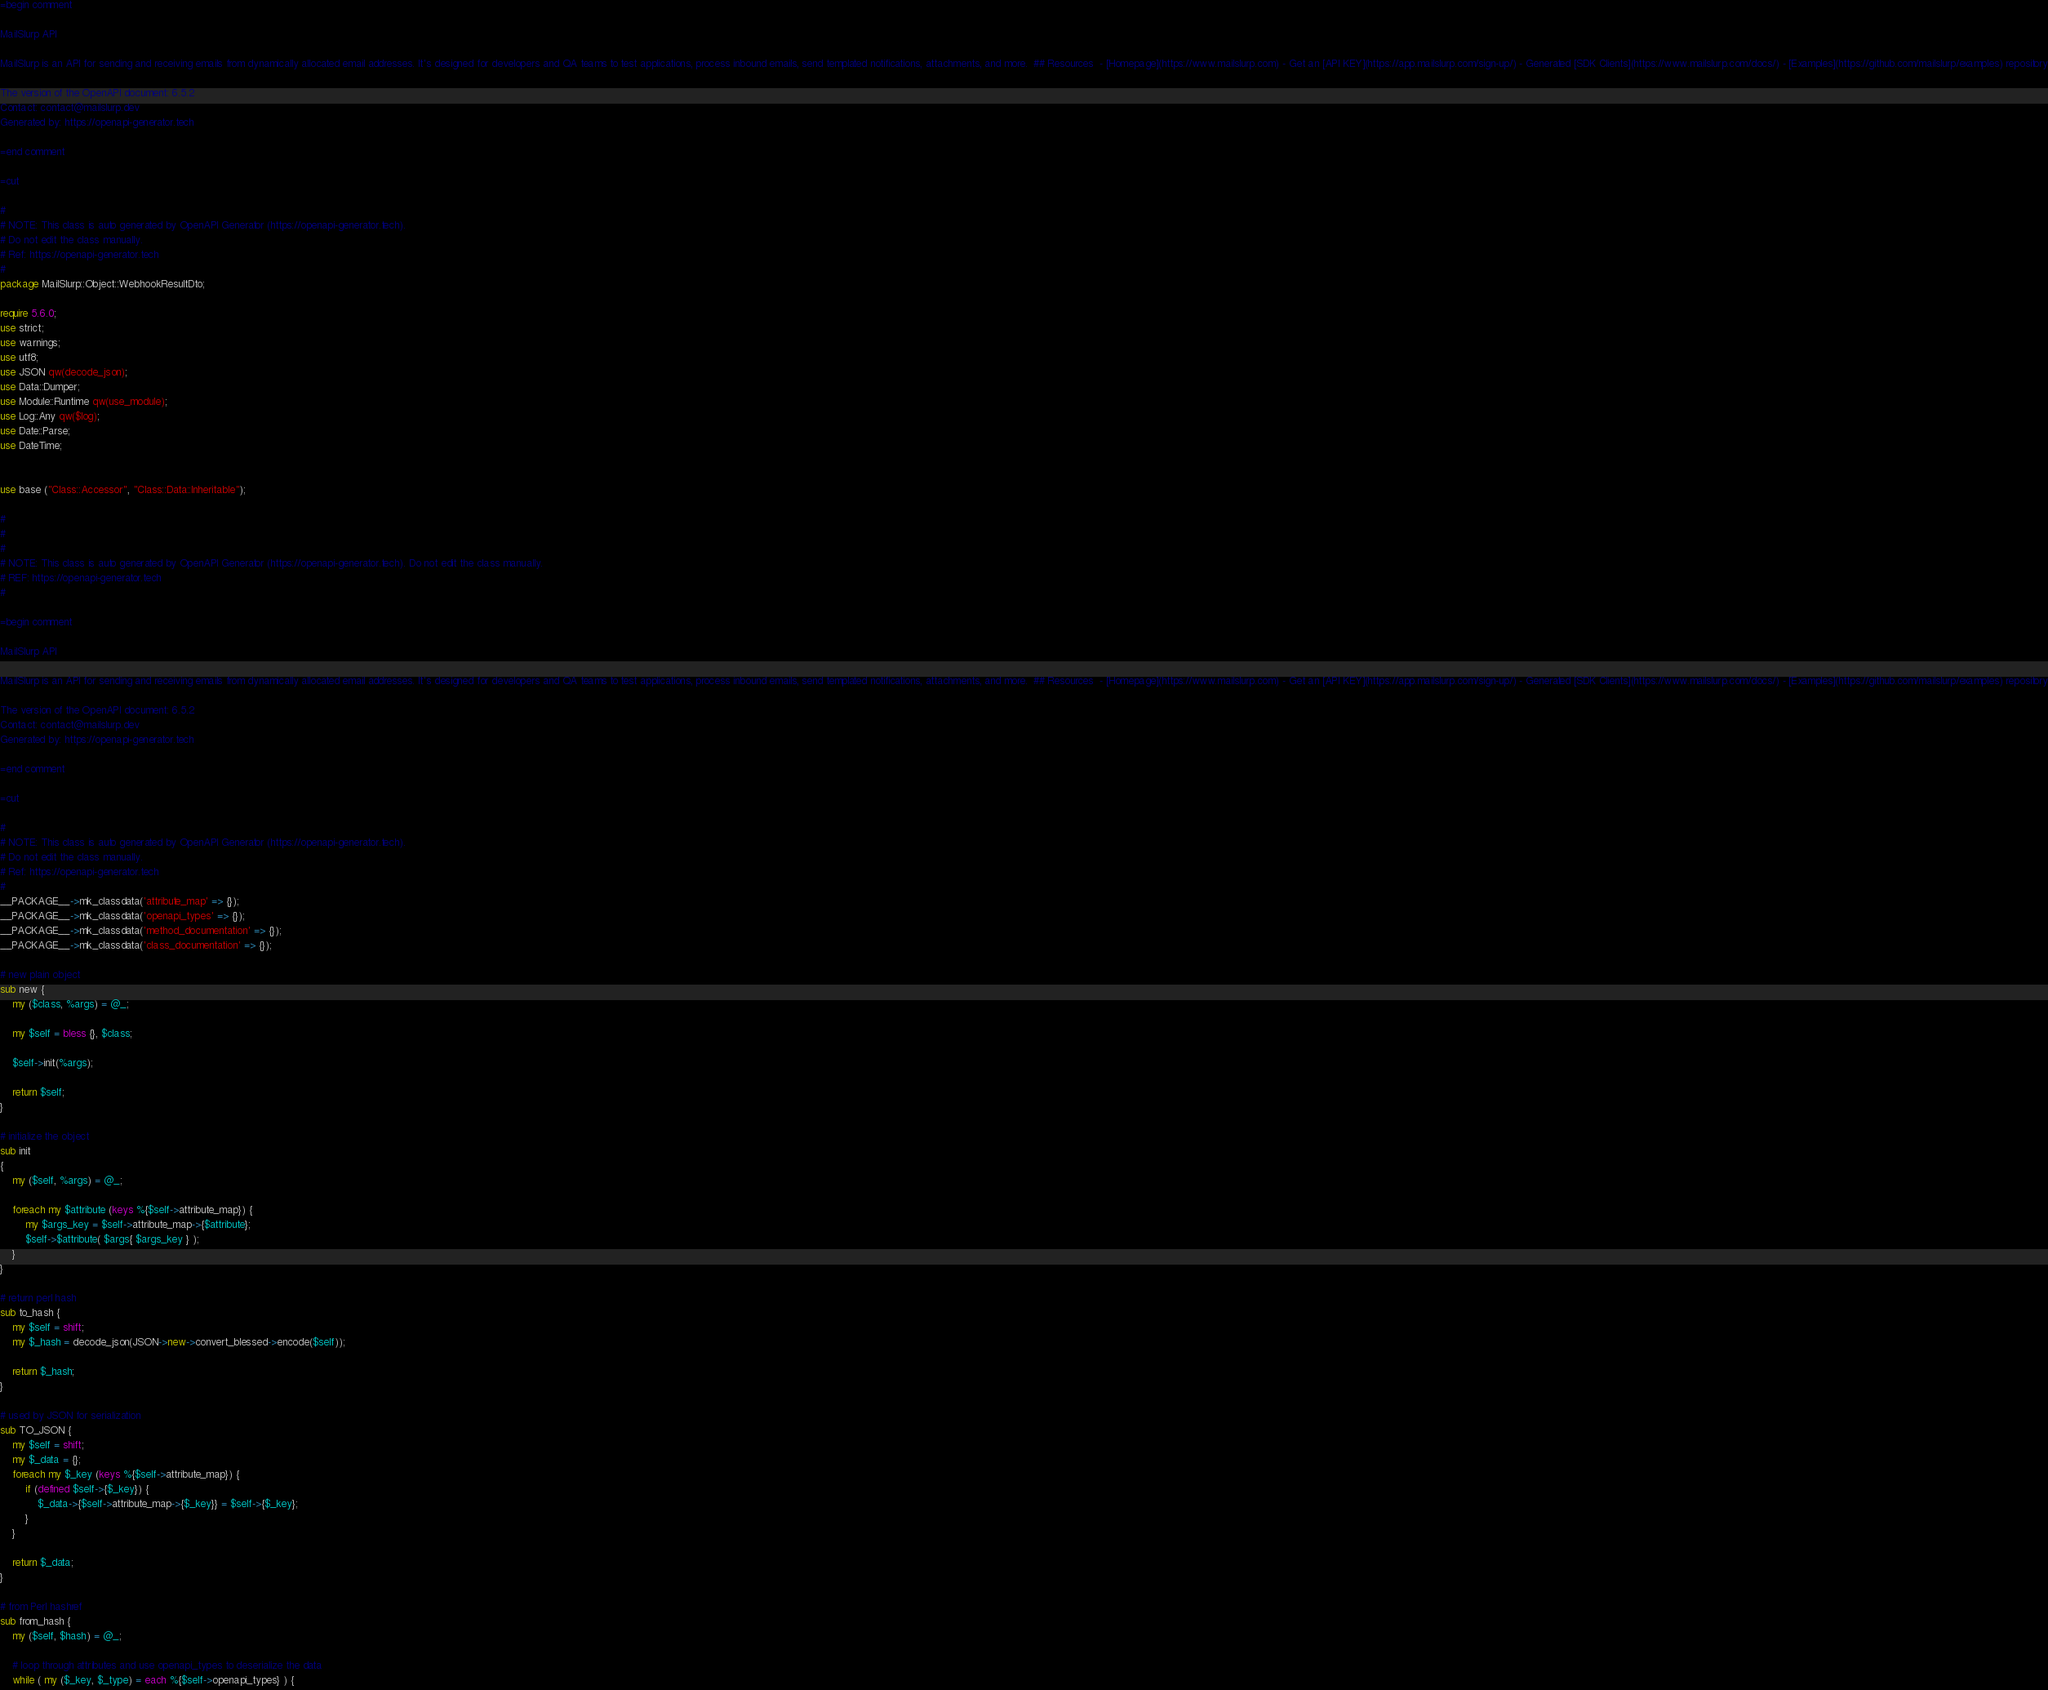<code> <loc_0><loc_0><loc_500><loc_500><_Perl_>=begin comment

MailSlurp API

MailSlurp is an API for sending and receiving emails from dynamically allocated email addresses. It's designed for developers and QA teams to test applications, process inbound emails, send templated notifications, attachments, and more.  ## Resources  - [Homepage](https://www.mailslurp.com) - Get an [API KEY](https://app.mailslurp.com/sign-up/) - Generated [SDK Clients](https://www.mailslurp.com/docs/) - [Examples](https://github.com/mailslurp/examples) repository

The version of the OpenAPI document: 6.5.2
Contact: contact@mailslurp.dev
Generated by: https://openapi-generator.tech

=end comment

=cut

#
# NOTE: This class is auto generated by OpenAPI Generator (https://openapi-generator.tech).
# Do not edit the class manually.
# Ref: https://openapi-generator.tech
#
package MailSlurp::Object::WebhookResultDto;

require 5.6.0;
use strict;
use warnings;
use utf8;
use JSON qw(decode_json);
use Data::Dumper;
use Module::Runtime qw(use_module);
use Log::Any qw($log);
use Date::Parse;
use DateTime;


use base ("Class::Accessor", "Class::Data::Inheritable");

#
#
#
# NOTE: This class is auto generated by OpenAPI Generator (https://openapi-generator.tech). Do not edit the class manually.
# REF: https://openapi-generator.tech
#

=begin comment

MailSlurp API

MailSlurp is an API for sending and receiving emails from dynamically allocated email addresses. It's designed for developers and QA teams to test applications, process inbound emails, send templated notifications, attachments, and more.  ## Resources  - [Homepage](https://www.mailslurp.com) - Get an [API KEY](https://app.mailslurp.com/sign-up/) - Generated [SDK Clients](https://www.mailslurp.com/docs/) - [Examples](https://github.com/mailslurp/examples) repository

The version of the OpenAPI document: 6.5.2
Contact: contact@mailslurp.dev
Generated by: https://openapi-generator.tech

=end comment

=cut

#
# NOTE: This class is auto generated by OpenAPI Generator (https://openapi-generator.tech).
# Do not edit the class manually.
# Ref: https://openapi-generator.tech
#
__PACKAGE__->mk_classdata('attribute_map' => {});
__PACKAGE__->mk_classdata('openapi_types' => {});
__PACKAGE__->mk_classdata('method_documentation' => {}); 
__PACKAGE__->mk_classdata('class_documentation' => {});

# new plain object
sub new { 
    my ($class, %args) = @_; 

    my $self = bless {}, $class;

    $self->init(%args);
    
    return $self;
}

# initialize the object
sub init
{
    my ($self, %args) = @_;

    foreach my $attribute (keys %{$self->attribute_map}) {
        my $args_key = $self->attribute_map->{$attribute};
        $self->$attribute( $args{ $args_key } );
    }
}

# return perl hash
sub to_hash {
    my $self = shift;
    my $_hash = decode_json(JSON->new->convert_blessed->encode($self));

    return $_hash;
}

# used by JSON for serialization
sub TO_JSON { 
    my $self = shift;
    my $_data = {};
    foreach my $_key (keys %{$self->attribute_map}) {
        if (defined $self->{$_key}) {
            $_data->{$self->attribute_map->{$_key}} = $self->{$_key};
        }
    }

    return $_data;
}

# from Perl hashref
sub from_hash {
    my ($self, $hash) = @_;

    # loop through attributes and use openapi_types to deserialize the data
    while ( my ($_key, $_type) = each %{$self->openapi_types} ) {</code> 